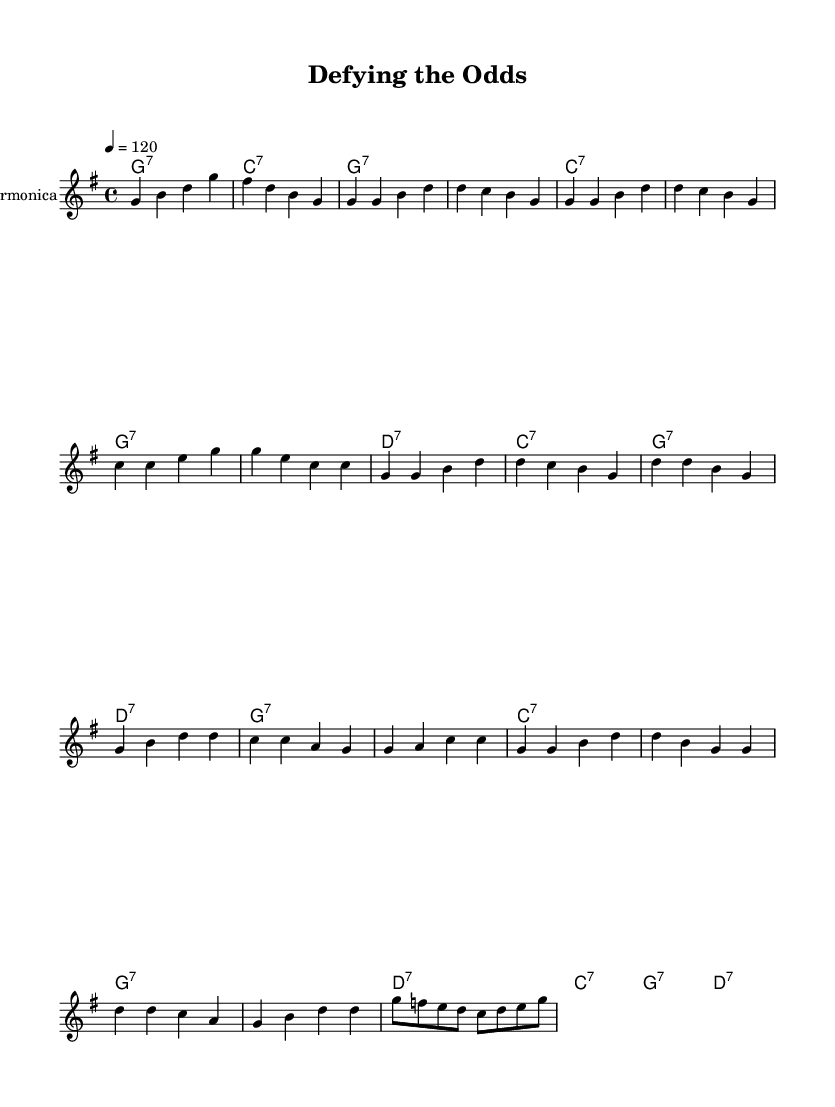What is the key signature of this music? The key signature shows one sharp (F#), indicating that the music is in G major.
Answer: G major What is the time signature of this piece? The time signature is indicated at the beginning of the score, which shows 4/4, meaning there are four beats in each measure.
Answer: 4/4 What is the tempo of this piece? The tempo marking states "4 = 120," meaning each quarter note is played at a speed of 120 beats per minute.
Answer: 120 How many measures are in the verse section? Counting the measures in the verse part of the score shows there are five measures listed before moving to the chorus.
Answer: 5 What chord follows the D7 in the chorus? The chord progression in the chorus shows the D7 is followed by a C7, based on the chord changes indicated in the chord names.
Answer: C7 What is the primary instrument featured in this piece? The score indicates that the parts are scored for a harmonica, which is specified as the instrument name in the staff.
Answer: Harmonica What is the overall mood conveyed by this blues piece? The driving rhythm, upbeat tempo, and celebratory lyrics about defying expectations contribute to a lively and positive mood.
Answer: Upbeat 